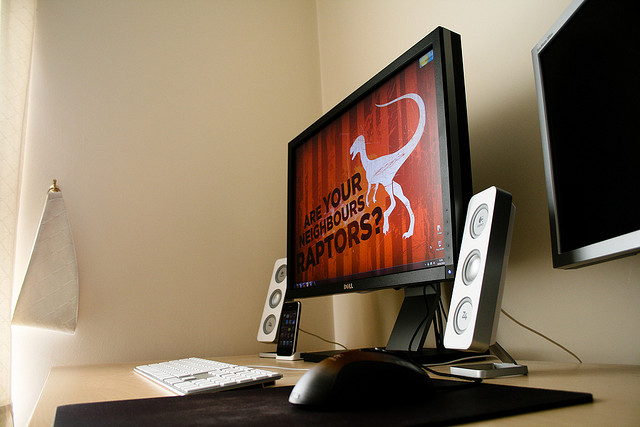Please identify all text content in this image. ARE YOUR ARE YOUR RAPTORS DELL 